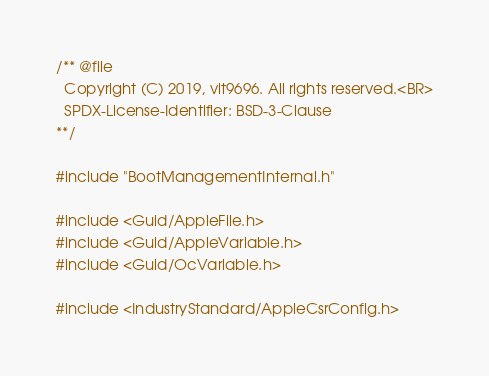Convert code to text. <code><loc_0><loc_0><loc_500><loc_500><_C_>/** @file
  Copyright (C) 2019, vit9696. All rights reserved.<BR>
  SPDX-License-Identifier: BSD-3-Clause
**/

#include "BootManagementInternal.h"

#include <Guid/AppleFile.h>
#include <Guid/AppleVariable.h>
#include <Guid/OcVariable.h>

#include <IndustryStandard/AppleCsrConfig.h>
</code> 